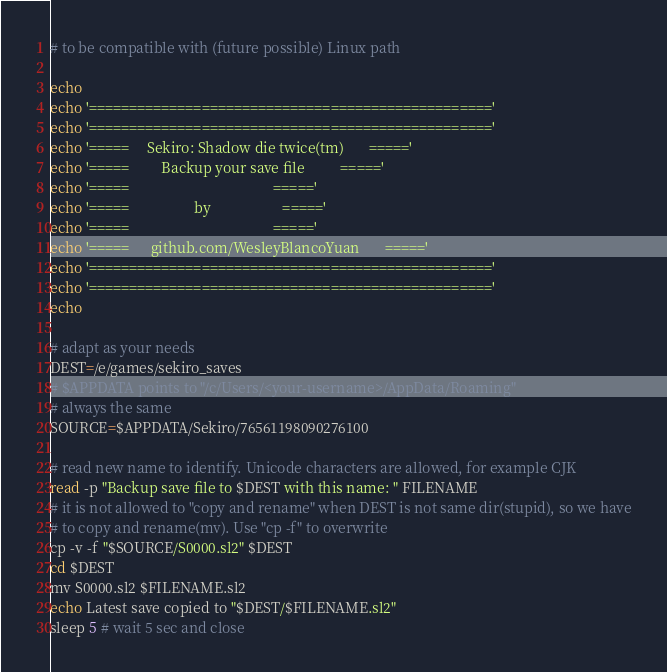<code> <loc_0><loc_0><loc_500><loc_500><_Bash_># to be compatible with (future possible) Linux path

echo 
echo '=================================================='
echo '=================================================='
echo '=====     Sekiro: Shadow die twice(tm)       ====='
echo '=====         Backup your save file          ====='
echo '=====                                        ====='
echo '=====                  by                    ====='
echo '=====                                        ====='
echo '=====      github.com/WesleyBlancoYuan       ====='
echo '=================================================='
echo '=================================================='
echo 

# adapt as your needs
DEST=/e/games/sekiro_saves
# $APPDATA points to "/c/Users/<your-username>/AppData/Roaming"
# always the same
SOURCE=$APPDATA/Sekiro/76561198090276100

# read new name to identify. Unicode characters are allowed, for example CJK
read -p "Backup save file to $DEST with this name: " FILENAME
# it is not allowed to "copy and rename" when DEST is not same dir(stupid), so we have
# to copy and rename(mv). Use "cp -f" to overwrite
cp -v -f "$SOURCE/S0000.sl2" $DEST
cd $DEST
mv S0000.sl2 $FILENAME.sl2
echo Latest save copied to "$DEST/$FILENAME.sl2"
sleep 5 # wait 5 sec and close
</code> 